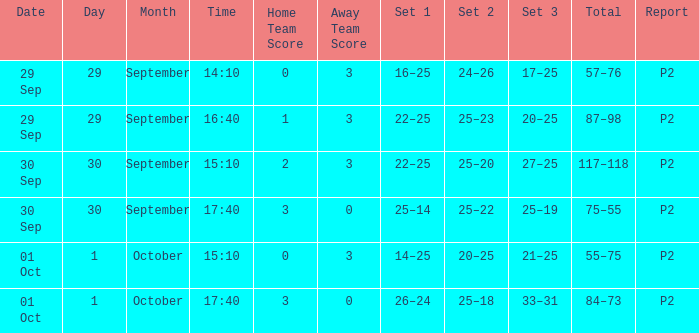What score corresponds to a time of 14:10? 0–3. Would you be able to parse every entry in this table? {'header': ['Date', 'Day', 'Month', 'Time', 'Home Team Score', 'Away Team Score', 'Set 1', 'Set 2', 'Set 3', 'Total', 'Report'], 'rows': [['29 Sep', '29', 'September', '14:10', '0', '3', '16–25', '24–26', '17–25', '57–76', 'P2'], ['29 Sep', '29', 'September', '16:40', '1', '3', '22–25', '25–23', '20–25', '87–98', 'P2'], ['30 Sep', '30', 'September', '15:10', '2', '3', '22–25', '25–20', '27–25', '117–118', 'P2'], ['30 Sep', '30', 'September', '17:40', '3', '0', '25–14', '25–22', '25–19', '75–55', 'P2'], ['01 Oct', '1', 'October', '15:10', '0', '3', '14–25', '20–25', '21–25', '55–75', 'P2'], ['01 Oct', '1', 'October', '17:40', '3', '0', '26–24', '25–18', '33–31', '84–73', 'P2']]} 